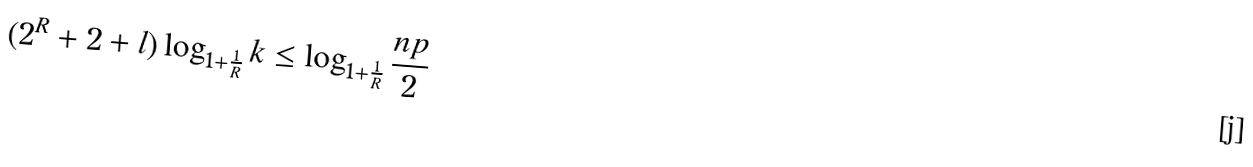<formula> <loc_0><loc_0><loc_500><loc_500>( 2 ^ { R } + 2 + l ) \log _ { 1 + \frac { 1 } { R } } k \leq \log _ { 1 + \frac { 1 } { R } } \frac { n p } { 2 }</formula> 